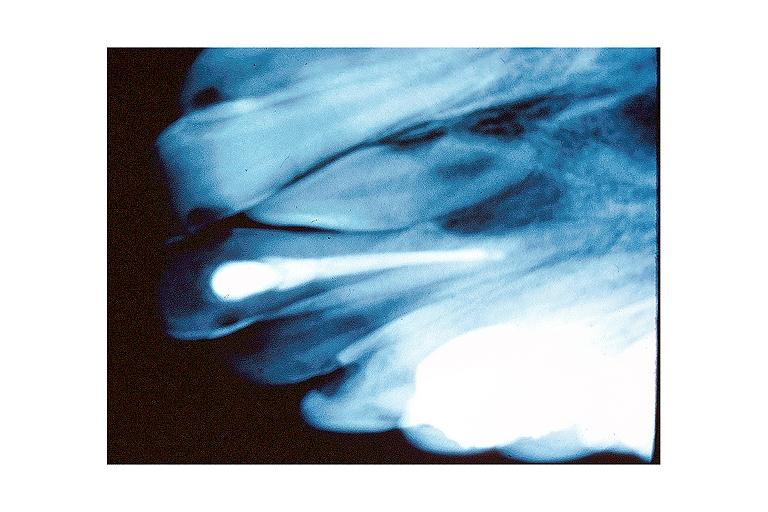s sarcoidosis present?
Answer the question using a single word or phrase. No 